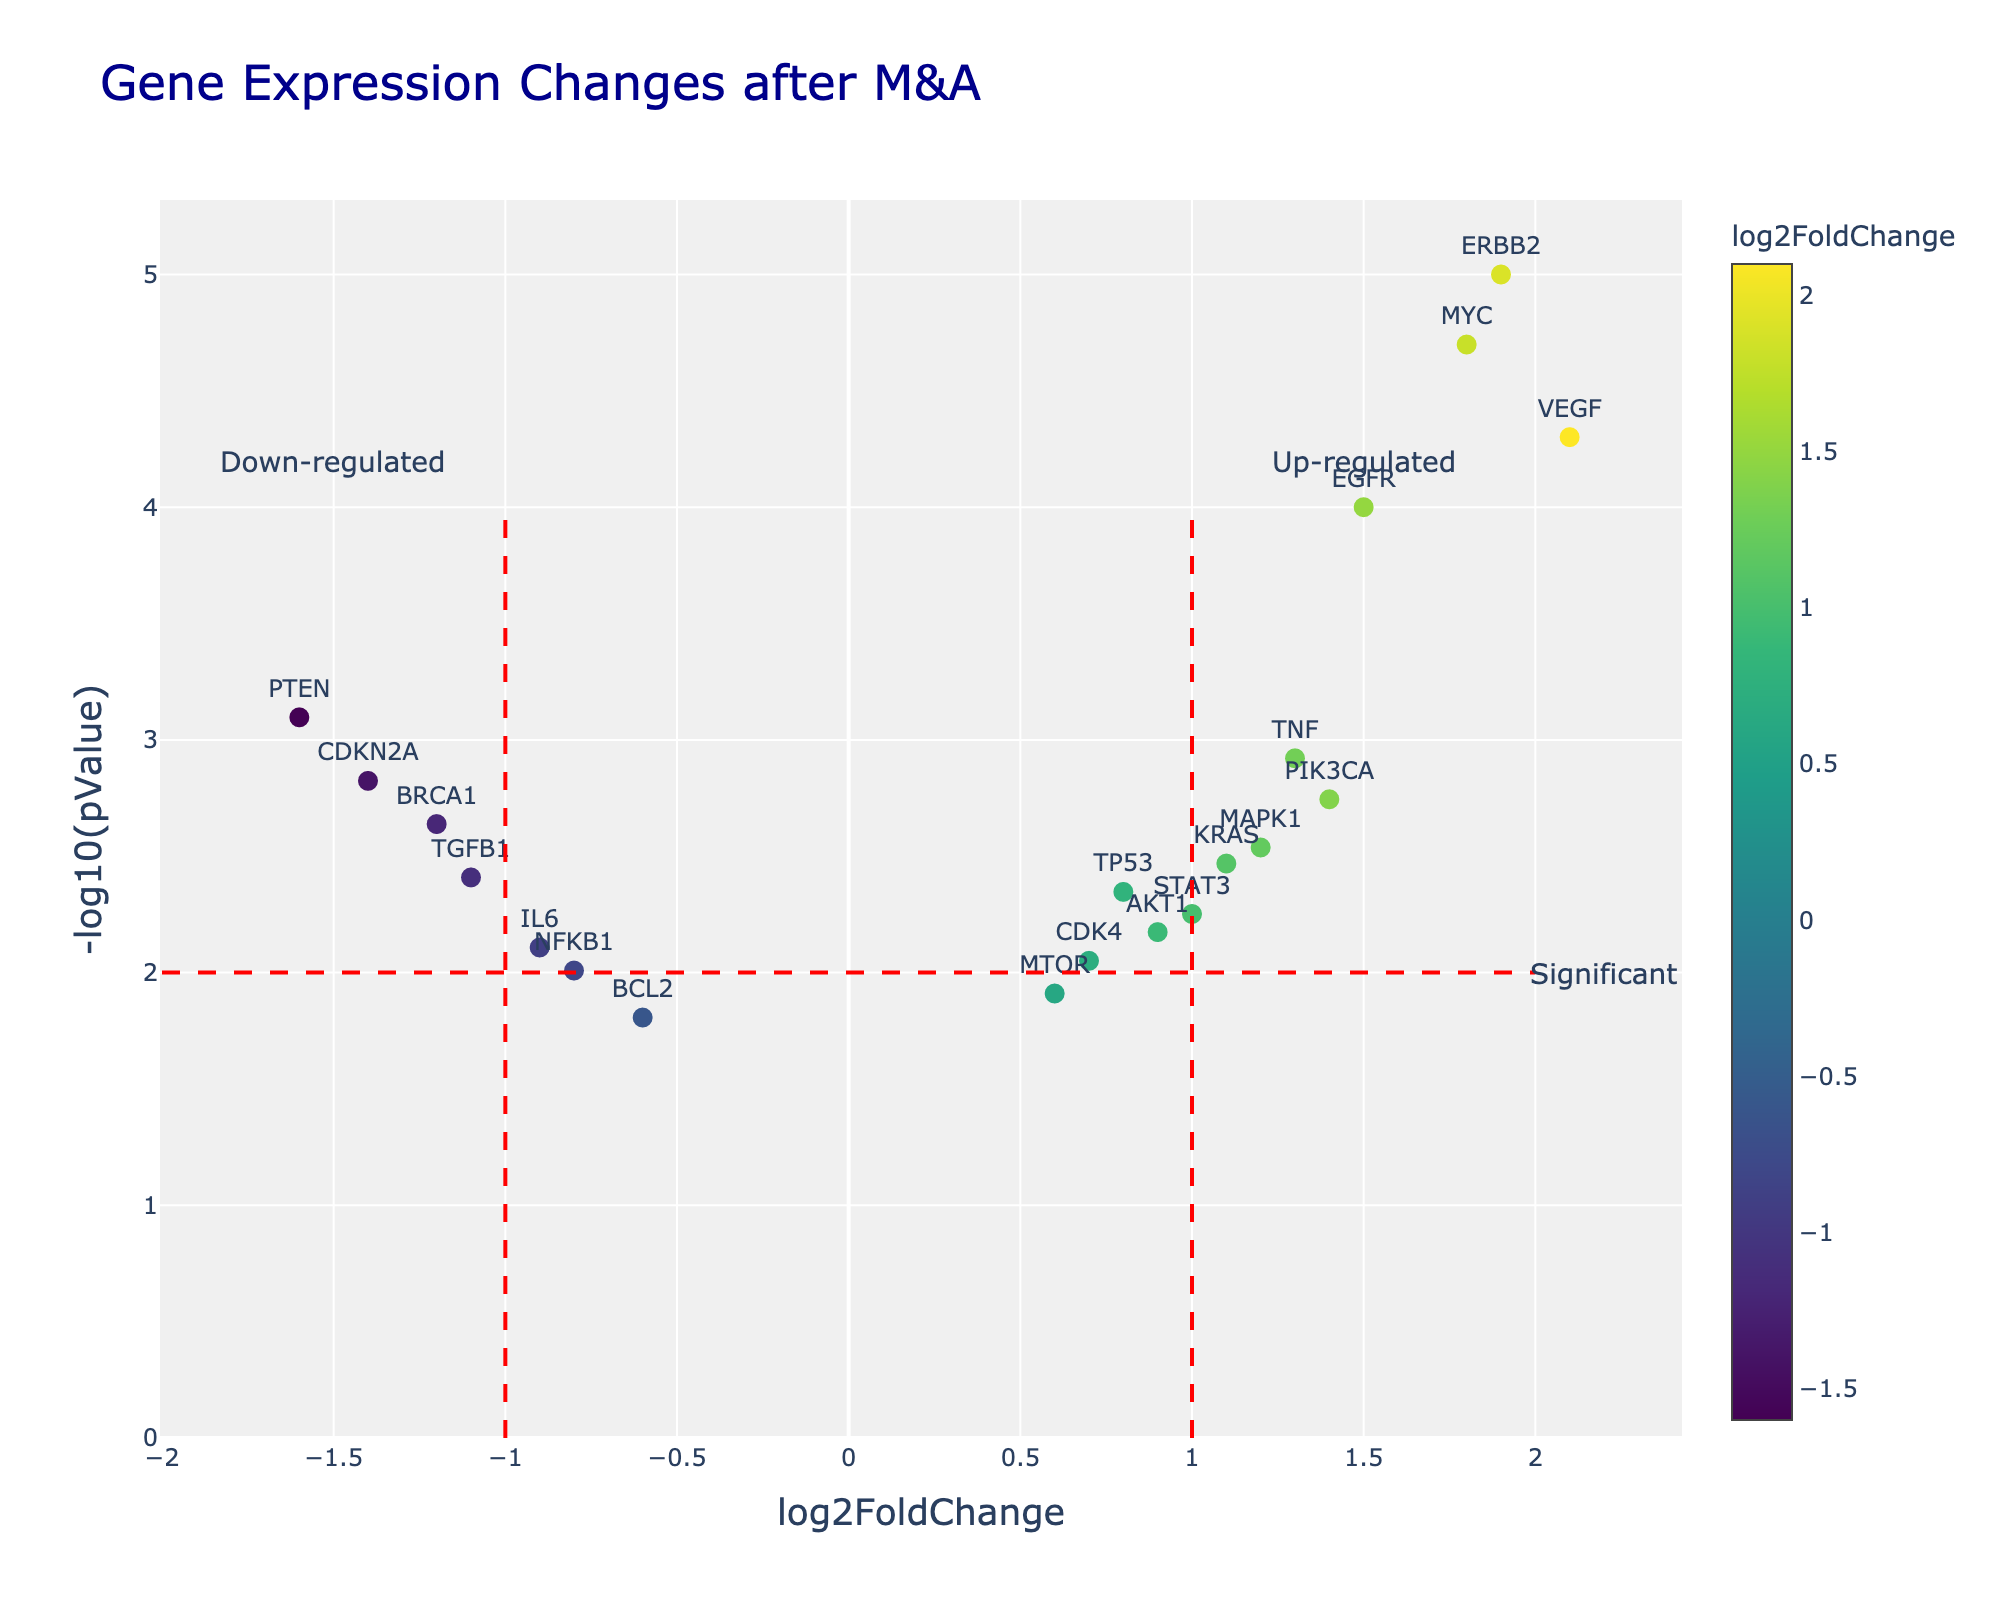What is the title of the figure? You can find the title at the top of the plot. Here it reads "Gene Expression Changes after M&A".
Answer: Gene Expression Changes after M&A How many genes have a log2FoldChange greater than 1.5? Look at the x-axis and count the points to the right of 1.5. There are two points (VEGF and MYC) with log2FoldChange greater than 1.5.
Answer: 2 Which gene has the highest log2FoldChange value? Identify the point furthest to the right on the x-axis. VEGF has a log2FoldChange of 2.1.
Answer: VEGF What does the y-axis represent in this plot? The y-axis is labeled "-log10(pValue)", indicating it shows the negative log base 10 of the p-value for each gene.
Answer: -log10(pValue) How many genes are considered significantly expressed (above the red dash line at y=2)? Count the points above the horizontal red dash line at y=2. There are ten data points above the line.
Answer: 10 Which gene has the smallest pValue, and what is its corresponding -log10(pValue)? The smallest pValue indicates the highest point on the y-axis. ERBB2 has the smallest pValue with a -log10(pValue) of approximately 5.
Answer: ERBB2, 5 How many genes are down-regulated with a significant pValue? Count the points to the left of x = -1 and above y = 2. Genes in this region are down-regulated and have significant p-values. There are three genes (BRCA1, PTEN, and CDKN2A) in this category.
Answer: 3 Between EGFR and PIK3CA, which gene is more significantly expressed based on the pValue? Compare the y-axis values (negative log10 of pValue). EGFR has a higher y-value than PIK3CA, indicating a more significant expression.
Answer: EGFR What range of log2FoldChange values is considered not differentially expressed based on the plotted significance threshold lines? The vertical red dash lines at x = -1 and x = 1 indicate the range for not differentially expressed genes. Values between -1 and 1 are considered not differentially expressed.
Answer: between -1 and 1 What data is provided when you hover over the gene TNF in the plot? When you hover over TNF, the plot shows "TNF<br>log2FoldChange: 1.3<br>-log10(pValue): 2.92".
Answer: TNF<br>log2FoldChange: 1.3<br>-log10(pValue): 2.92 